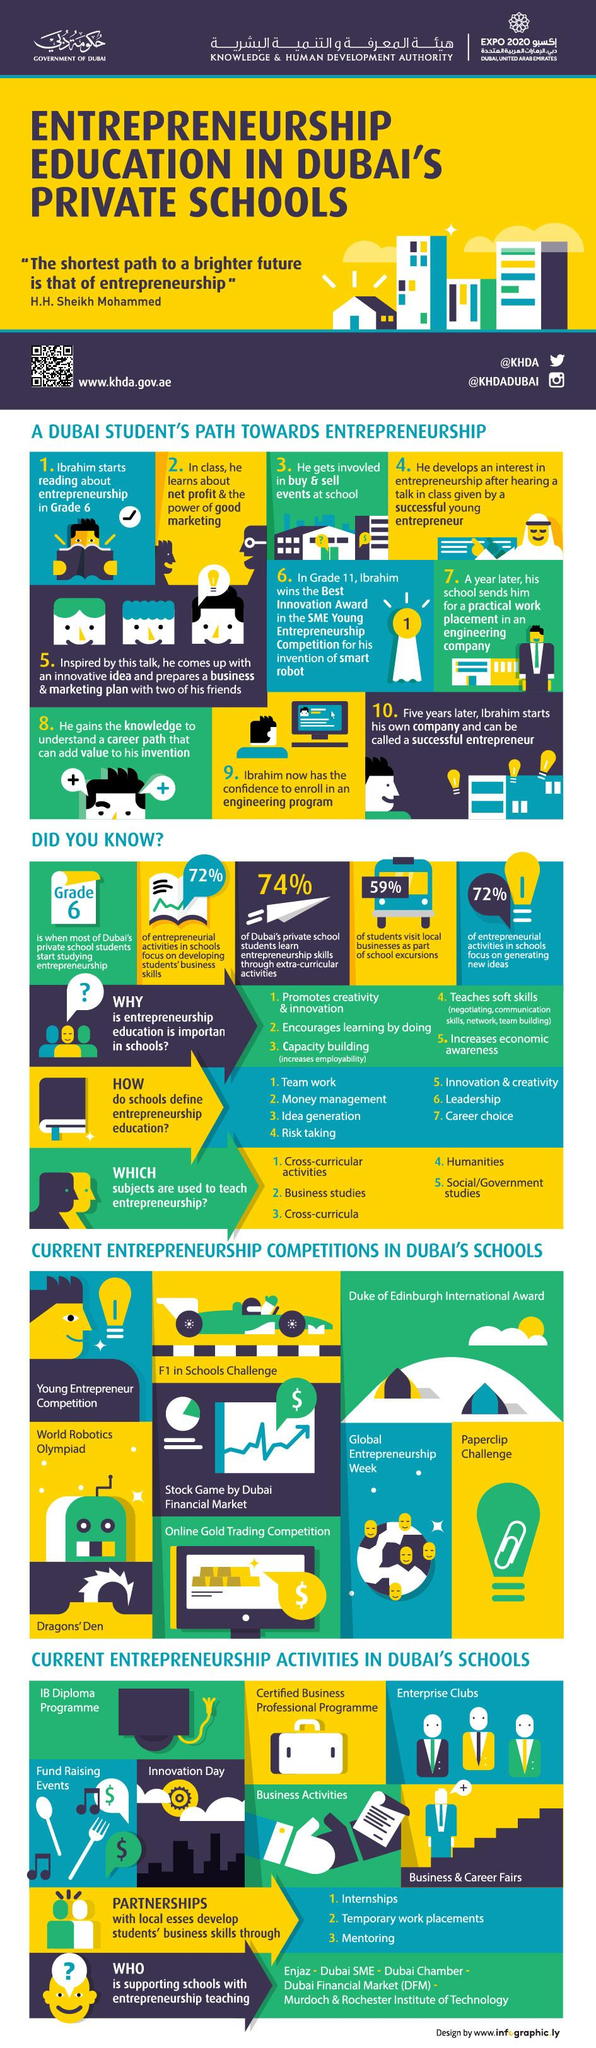Indicate a few pertinent items in this graphic. According to a recent study, 59% of students in Dubai participate in school excursions that visit local businesses. In Dubai's private schools, students typically begin studying entrepreneurship in grade 6. According to studies, a significant majority of entrepreneurial activities in schools are focused on generating new ideas, with 72% of such activities dedicated to this goal. In Dubai, 74% of private school students learn entrepreneurship skills through extra-curricular activities. 